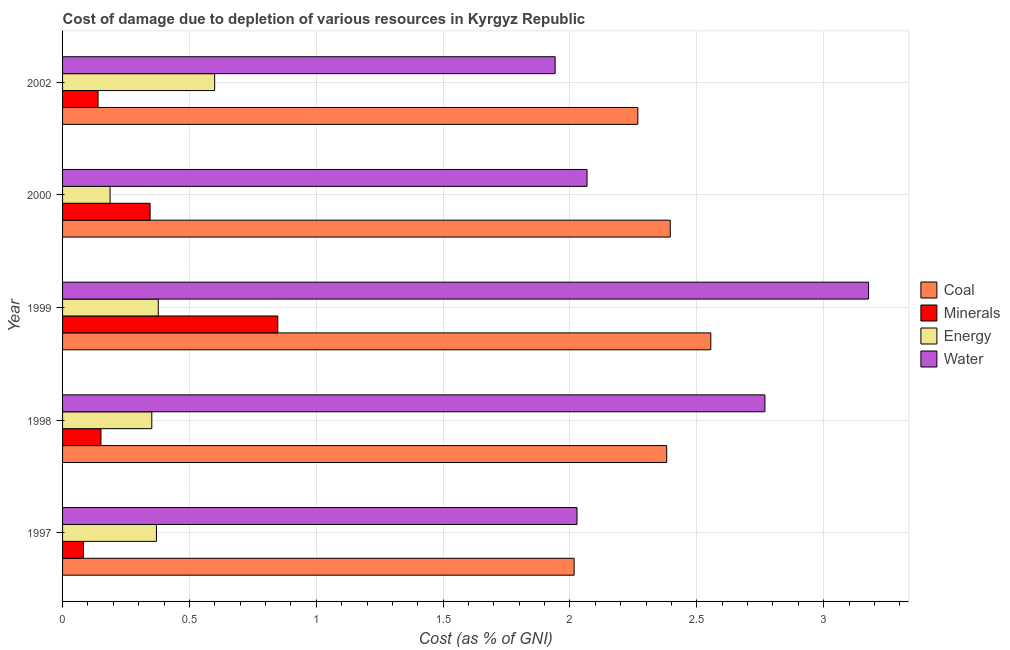How many different coloured bars are there?
Your response must be concise. 4. Are the number of bars per tick equal to the number of legend labels?
Give a very brief answer. Yes. Are the number of bars on each tick of the Y-axis equal?
Provide a succinct answer. Yes. How many bars are there on the 3rd tick from the top?
Give a very brief answer. 4. In how many cases, is the number of bars for a given year not equal to the number of legend labels?
Give a very brief answer. 0. What is the cost of damage due to depletion of minerals in 1997?
Make the answer very short. 0.08. Across all years, what is the maximum cost of damage due to depletion of minerals?
Offer a very short reply. 0.85. Across all years, what is the minimum cost of damage due to depletion of minerals?
Offer a very short reply. 0.08. In which year was the cost of damage due to depletion of energy minimum?
Keep it short and to the point. 2000. What is the total cost of damage due to depletion of coal in the graph?
Give a very brief answer. 11.62. What is the difference between the cost of damage due to depletion of minerals in 1997 and that in 1999?
Keep it short and to the point. -0.77. What is the difference between the cost of damage due to depletion of minerals in 2002 and the cost of damage due to depletion of water in 1998?
Your answer should be very brief. -2.63. What is the average cost of damage due to depletion of minerals per year?
Your answer should be very brief. 0.31. In the year 2000, what is the difference between the cost of damage due to depletion of energy and cost of damage due to depletion of minerals?
Your answer should be very brief. -0.16. In how many years, is the cost of damage due to depletion of energy greater than 1.7 %?
Offer a terse response. 0. What is the ratio of the cost of damage due to depletion of minerals in 2000 to that in 2002?
Provide a succinct answer. 2.47. Is the difference between the cost of damage due to depletion of water in 1997 and 1999 greater than the difference between the cost of damage due to depletion of minerals in 1997 and 1999?
Your response must be concise. No. What is the difference between the highest and the second highest cost of damage due to depletion of minerals?
Provide a short and direct response. 0.5. What is the difference between the highest and the lowest cost of damage due to depletion of energy?
Provide a short and direct response. 0.41. In how many years, is the cost of damage due to depletion of coal greater than the average cost of damage due to depletion of coal taken over all years?
Your answer should be very brief. 3. Is the sum of the cost of damage due to depletion of coal in 1998 and 1999 greater than the maximum cost of damage due to depletion of energy across all years?
Keep it short and to the point. Yes. What does the 3rd bar from the top in 1998 represents?
Provide a short and direct response. Minerals. What does the 2nd bar from the bottom in 2002 represents?
Give a very brief answer. Minerals. Is it the case that in every year, the sum of the cost of damage due to depletion of coal and cost of damage due to depletion of minerals is greater than the cost of damage due to depletion of energy?
Provide a succinct answer. Yes. How many bars are there?
Ensure brevity in your answer.  20. Does the graph contain grids?
Offer a terse response. Yes. How many legend labels are there?
Ensure brevity in your answer.  4. How are the legend labels stacked?
Provide a succinct answer. Vertical. What is the title of the graph?
Your answer should be compact. Cost of damage due to depletion of various resources in Kyrgyz Republic . What is the label or title of the X-axis?
Your response must be concise. Cost (as % of GNI). What is the Cost (as % of GNI) in Coal in 1997?
Your answer should be very brief. 2.02. What is the Cost (as % of GNI) in Minerals in 1997?
Offer a very short reply. 0.08. What is the Cost (as % of GNI) in Energy in 1997?
Keep it short and to the point. 0.37. What is the Cost (as % of GNI) of Water in 1997?
Your answer should be very brief. 2.03. What is the Cost (as % of GNI) of Coal in 1998?
Provide a succinct answer. 2.38. What is the Cost (as % of GNI) in Minerals in 1998?
Offer a very short reply. 0.15. What is the Cost (as % of GNI) in Energy in 1998?
Ensure brevity in your answer.  0.35. What is the Cost (as % of GNI) in Water in 1998?
Ensure brevity in your answer.  2.77. What is the Cost (as % of GNI) in Coal in 1999?
Your answer should be compact. 2.56. What is the Cost (as % of GNI) of Minerals in 1999?
Provide a succinct answer. 0.85. What is the Cost (as % of GNI) in Energy in 1999?
Give a very brief answer. 0.38. What is the Cost (as % of GNI) of Water in 1999?
Offer a very short reply. 3.18. What is the Cost (as % of GNI) in Coal in 2000?
Keep it short and to the point. 2.4. What is the Cost (as % of GNI) of Minerals in 2000?
Offer a very short reply. 0.35. What is the Cost (as % of GNI) of Energy in 2000?
Give a very brief answer. 0.19. What is the Cost (as % of GNI) of Water in 2000?
Offer a very short reply. 2.07. What is the Cost (as % of GNI) of Coal in 2002?
Keep it short and to the point. 2.27. What is the Cost (as % of GNI) of Minerals in 2002?
Your answer should be very brief. 0.14. What is the Cost (as % of GNI) in Energy in 2002?
Keep it short and to the point. 0.6. What is the Cost (as % of GNI) in Water in 2002?
Your response must be concise. 1.94. Across all years, what is the maximum Cost (as % of GNI) of Coal?
Your answer should be very brief. 2.56. Across all years, what is the maximum Cost (as % of GNI) in Minerals?
Keep it short and to the point. 0.85. Across all years, what is the maximum Cost (as % of GNI) in Energy?
Your response must be concise. 0.6. Across all years, what is the maximum Cost (as % of GNI) of Water?
Provide a succinct answer. 3.18. Across all years, what is the minimum Cost (as % of GNI) of Coal?
Provide a short and direct response. 2.02. Across all years, what is the minimum Cost (as % of GNI) in Minerals?
Provide a short and direct response. 0.08. Across all years, what is the minimum Cost (as % of GNI) in Energy?
Offer a very short reply. 0.19. Across all years, what is the minimum Cost (as % of GNI) in Water?
Make the answer very short. 1.94. What is the total Cost (as % of GNI) in Coal in the graph?
Offer a very short reply. 11.62. What is the total Cost (as % of GNI) in Minerals in the graph?
Make the answer very short. 1.57. What is the total Cost (as % of GNI) in Energy in the graph?
Make the answer very short. 1.89. What is the total Cost (as % of GNI) in Water in the graph?
Offer a terse response. 11.98. What is the difference between the Cost (as % of GNI) of Coal in 1997 and that in 1998?
Provide a short and direct response. -0.36. What is the difference between the Cost (as % of GNI) of Minerals in 1997 and that in 1998?
Ensure brevity in your answer.  -0.07. What is the difference between the Cost (as % of GNI) in Energy in 1997 and that in 1998?
Make the answer very short. 0.02. What is the difference between the Cost (as % of GNI) in Water in 1997 and that in 1998?
Ensure brevity in your answer.  -0.74. What is the difference between the Cost (as % of GNI) in Coal in 1997 and that in 1999?
Provide a succinct answer. -0.54. What is the difference between the Cost (as % of GNI) in Minerals in 1997 and that in 1999?
Offer a terse response. -0.77. What is the difference between the Cost (as % of GNI) of Energy in 1997 and that in 1999?
Ensure brevity in your answer.  -0.01. What is the difference between the Cost (as % of GNI) in Water in 1997 and that in 1999?
Keep it short and to the point. -1.15. What is the difference between the Cost (as % of GNI) in Coal in 1997 and that in 2000?
Your answer should be very brief. -0.38. What is the difference between the Cost (as % of GNI) of Minerals in 1997 and that in 2000?
Your answer should be compact. -0.26. What is the difference between the Cost (as % of GNI) of Energy in 1997 and that in 2000?
Offer a very short reply. 0.18. What is the difference between the Cost (as % of GNI) in Water in 1997 and that in 2000?
Your answer should be very brief. -0.04. What is the difference between the Cost (as % of GNI) in Coal in 1997 and that in 2002?
Provide a short and direct response. -0.25. What is the difference between the Cost (as % of GNI) in Minerals in 1997 and that in 2002?
Give a very brief answer. -0.06. What is the difference between the Cost (as % of GNI) of Energy in 1997 and that in 2002?
Your response must be concise. -0.23. What is the difference between the Cost (as % of GNI) in Water in 1997 and that in 2002?
Provide a succinct answer. 0.09. What is the difference between the Cost (as % of GNI) of Coal in 1998 and that in 1999?
Keep it short and to the point. -0.17. What is the difference between the Cost (as % of GNI) in Minerals in 1998 and that in 1999?
Your response must be concise. -0.7. What is the difference between the Cost (as % of GNI) of Energy in 1998 and that in 1999?
Keep it short and to the point. -0.03. What is the difference between the Cost (as % of GNI) in Water in 1998 and that in 1999?
Make the answer very short. -0.41. What is the difference between the Cost (as % of GNI) of Coal in 1998 and that in 2000?
Ensure brevity in your answer.  -0.01. What is the difference between the Cost (as % of GNI) in Minerals in 1998 and that in 2000?
Make the answer very short. -0.19. What is the difference between the Cost (as % of GNI) of Energy in 1998 and that in 2000?
Offer a terse response. 0.16. What is the difference between the Cost (as % of GNI) in Water in 1998 and that in 2000?
Your response must be concise. 0.7. What is the difference between the Cost (as % of GNI) of Coal in 1998 and that in 2002?
Give a very brief answer. 0.11. What is the difference between the Cost (as % of GNI) in Minerals in 1998 and that in 2002?
Keep it short and to the point. 0.01. What is the difference between the Cost (as % of GNI) in Energy in 1998 and that in 2002?
Offer a terse response. -0.25. What is the difference between the Cost (as % of GNI) in Water in 1998 and that in 2002?
Provide a succinct answer. 0.83. What is the difference between the Cost (as % of GNI) in Coal in 1999 and that in 2000?
Your response must be concise. 0.16. What is the difference between the Cost (as % of GNI) of Minerals in 1999 and that in 2000?
Provide a short and direct response. 0.5. What is the difference between the Cost (as % of GNI) in Energy in 1999 and that in 2000?
Keep it short and to the point. 0.19. What is the difference between the Cost (as % of GNI) of Water in 1999 and that in 2000?
Keep it short and to the point. 1.11. What is the difference between the Cost (as % of GNI) of Coal in 1999 and that in 2002?
Provide a short and direct response. 0.29. What is the difference between the Cost (as % of GNI) of Minerals in 1999 and that in 2002?
Your answer should be compact. 0.71. What is the difference between the Cost (as % of GNI) of Energy in 1999 and that in 2002?
Give a very brief answer. -0.22. What is the difference between the Cost (as % of GNI) in Water in 1999 and that in 2002?
Provide a succinct answer. 1.24. What is the difference between the Cost (as % of GNI) of Coal in 2000 and that in 2002?
Provide a succinct answer. 0.13. What is the difference between the Cost (as % of GNI) in Minerals in 2000 and that in 2002?
Provide a short and direct response. 0.21. What is the difference between the Cost (as % of GNI) in Energy in 2000 and that in 2002?
Provide a short and direct response. -0.41. What is the difference between the Cost (as % of GNI) in Water in 2000 and that in 2002?
Ensure brevity in your answer.  0.13. What is the difference between the Cost (as % of GNI) in Coal in 1997 and the Cost (as % of GNI) in Minerals in 1998?
Your response must be concise. 1.87. What is the difference between the Cost (as % of GNI) in Coal in 1997 and the Cost (as % of GNI) in Energy in 1998?
Provide a succinct answer. 1.66. What is the difference between the Cost (as % of GNI) of Coal in 1997 and the Cost (as % of GNI) of Water in 1998?
Make the answer very short. -0.75. What is the difference between the Cost (as % of GNI) of Minerals in 1997 and the Cost (as % of GNI) of Energy in 1998?
Offer a terse response. -0.27. What is the difference between the Cost (as % of GNI) in Minerals in 1997 and the Cost (as % of GNI) in Water in 1998?
Provide a succinct answer. -2.69. What is the difference between the Cost (as % of GNI) in Energy in 1997 and the Cost (as % of GNI) in Water in 1998?
Offer a terse response. -2.4. What is the difference between the Cost (as % of GNI) in Coal in 1997 and the Cost (as % of GNI) in Minerals in 1999?
Make the answer very short. 1.17. What is the difference between the Cost (as % of GNI) in Coal in 1997 and the Cost (as % of GNI) in Energy in 1999?
Keep it short and to the point. 1.64. What is the difference between the Cost (as % of GNI) in Coal in 1997 and the Cost (as % of GNI) in Water in 1999?
Your answer should be compact. -1.16. What is the difference between the Cost (as % of GNI) of Minerals in 1997 and the Cost (as % of GNI) of Energy in 1999?
Your answer should be very brief. -0.29. What is the difference between the Cost (as % of GNI) of Minerals in 1997 and the Cost (as % of GNI) of Water in 1999?
Offer a very short reply. -3.09. What is the difference between the Cost (as % of GNI) of Energy in 1997 and the Cost (as % of GNI) of Water in 1999?
Your answer should be very brief. -2.81. What is the difference between the Cost (as % of GNI) in Coal in 1997 and the Cost (as % of GNI) in Minerals in 2000?
Your answer should be compact. 1.67. What is the difference between the Cost (as % of GNI) of Coal in 1997 and the Cost (as % of GNI) of Energy in 2000?
Offer a terse response. 1.83. What is the difference between the Cost (as % of GNI) of Coal in 1997 and the Cost (as % of GNI) of Water in 2000?
Offer a terse response. -0.05. What is the difference between the Cost (as % of GNI) of Minerals in 1997 and the Cost (as % of GNI) of Energy in 2000?
Keep it short and to the point. -0.1. What is the difference between the Cost (as % of GNI) of Minerals in 1997 and the Cost (as % of GNI) of Water in 2000?
Offer a terse response. -1.98. What is the difference between the Cost (as % of GNI) in Energy in 1997 and the Cost (as % of GNI) in Water in 2000?
Offer a terse response. -1.7. What is the difference between the Cost (as % of GNI) in Coal in 1997 and the Cost (as % of GNI) in Minerals in 2002?
Make the answer very short. 1.88. What is the difference between the Cost (as % of GNI) in Coal in 1997 and the Cost (as % of GNI) in Energy in 2002?
Your answer should be compact. 1.42. What is the difference between the Cost (as % of GNI) of Coal in 1997 and the Cost (as % of GNI) of Water in 2002?
Give a very brief answer. 0.07. What is the difference between the Cost (as % of GNI) of Minerals in 1997 and the Cost (as % of GNI) of Energy in 2002?
Make the answer very short. -0.52. What is the difference between the Cost (as % of GNI) of Minerals in 1997 and the Cost (as % of GNI) of Water in 2002?
Keep it short and to the point. -1.86. What is the difference between the Cost (as % of GNI) in Energy in 1997 and the Cost (as % of GNI) in Water in 2002?
Provide a succinct answer. -1.57. What is the difference between the Cost (as % of GNI) of Coal in 1998 and the Cost (as % of GNI) of Minerals in 1999?
Your response must be concise. 1.53. What is the difference between the Cost (as % of GNI) of Coal in 1998 and the Cost (as % of GNI) of Energy in 1999?
Keep it short and to the point. 2. What is the difference between the Cost (as % of GNI) of Coal in 1998 and the Cost (as % of GNI) of Water in 1999?
Ensure brevity in your answer.  -0.8. What is the difference between the Cost (as % of GNI) in Minerals in 1998 and the Cost (as % of GNI) in Energy in 1999?
Provide a short and direct response. -0.23. What is the difference between the Cost (as % of GNI) of Minerals in 1998 and the Cost (as % of GNI) of Water in 1999?
Provide a short and direct response. -3.03. What is the difference between the Cost (as % of GNI) in Energy in 1998 and the Cost (as % of GNI) in Water in 1999?
Offer a very short reply. -2.83. What is the difference between the Cost (as % of GNI) of Coal in 1998 and the Cost (as % of GNI) of Minerals in 2000?
Your answer should be compact. 2.04. What is the difference between the Cost (as % of GNI) in Coal in 1998 and the Cost (as % of GNI) in Energy in 2000?
Ensure brevity in your answer.  2.19. What is the difference between the Cost (as % of GNI) of Coal in 1998 and the Cost (as % of GNI) of Water in 2000?
Give a very brief answer. 0.31. What is the difference between the Cost (as % of GNI) of Minerals in 1998 and the Cost (as % of GNI) of Energy in 2000?
Make the answer very short. -0.04. What is the difference between the Cost (as % of GNI) in Minerals in 1998 and the Cost (as % of GNI) in Water in 2000?
Provide a short and direct response. -1.92. What is the difference between the Cost (as % of GNI) of Energy in 1998 and the Cost (as % of GNI) of Water in 2000?
Provide a succinct answer. -1.72. What is the difference between the Cost (as % of GNI) in Coal in 1998 and the Cost (as % of GNI) in Minerals in 2002?
Your answer should be very brief. 2.24. What is the difference between the Cost (as % of GNI) of Coal in 1998 and the Cost (as % of GNI) of Energy in 2002?
Make the answer very short. 1.78. What is the difference between the Cost (as % of GNI) of Coal in 1998 and the Cost (as % of GNI) of Water in 2002?
Give a very brief answer. 0.44. What is the difference between the Cost (as % of GNI) of Minerals in 1998 and the Cost (as % of GNI) of Energy in 2002?
Your answer should be compact. -0.45. What is the difference between the Cost (as % of GNI) in Minerals in 1998 and the Cost (as % of GNI) in Water in 2002?
Give a very brief answer. -1.79. What is the difference between the Cost (as % of GNI) in Energy in 1998 and the Cost (as % of GNI) in Water in 2002?
Your answer should be very brief. -1.59. What is the difference between the Cost (as % of GNI) in Coal in 1999 and the Cost (as % of GNI) in Minerals in 2000?
Provide a short and direct response. 2.21. What is the difference between the Cost (as % of GNI) of Coal in 1999 and the Cost (as % of GNI) of Energy in 2000?
Ensure brevity in your answer.  2.37. What is the difference between the Cost (as % of GNI) of Coal in 1999 and the Cost (as % of GNI) of Water in 2000?
Provide a succinct answer. 0.49. What is the difference between the Cost (as % of GNI) of Minerals in 1999 and the Cost (as % of GNI) of Energy in 2000?
Provide a succinct answer. 0.66. What is the difference between the Cost (as % of GNI) in Minerals in 1999 and the Cost (as % of GNI) in Water in 2000?
Provide a short and direct response. -1.22. What is the difference between the Cost (as % of GNI) of Energy in 1999 and the Cost (as % of GNI) of Water in 2000?
Your answer should be compact. -1.69. What is the difference between the Cost (as % of GNI) of Coal in 1999 and the Cost (as % of GNI) of Minerals in 2002?
Give a very brief answer. 2.42. What is the difference between the Cost (as % of GNI) in Coal in 1999 and the Cost (as % of GNI) in Energy in 2002?
Provide a short and direct response. 1.96. What is the difference between the Cost (as % of GNI) in Coal in 1999 and the Cost (as % of GNI) in Water in 2002?
Your answer should be very brief. 0.61. What is the difference between the Cost (as % of GNI) of Minerals in 1999 and the Cost (as % of GNI) of Energy in 2002?
Your answer should be very brief. 0.25. What is the difference between the Cost (as % of GNI) in Minerals in 1999 and the Cost (as % of GNI) in Water in 2002?
Offer a very short reply. -1.09. What is the difference between the Cost (as % of GNI) in Energy in 1999 and the Cost (as % of GNI) in Water in 2002?
Your answer should be very brief. -1.56. What is the difference between the Cost (as % of GNI) of Coal in 2000 and the Cost (as % of GNI) of Minerals in 2002?
Give a very brief answer. 2.26. What is the difference between the Cost (as % of GNI) of Coal in 2000 and the Cost (as % of GNI) of Energy in 2002?
Offer a terse response. 1.8. What is the difference between the Cost (as % of GNI) in Coal in 2000 and the Cost (as % of GNI) in Water in 2002?
Provide a short and direct response. 0.45. What is the difference between the Cost (as % of GNI) in Minerals in 2000 and the Cost (as % of GNI) in Energy in 2002?
Provide a short and direct response. -0.25. What is the difference between the Cost (as % of GNI) in Minerals in 2000 and the Cost (as % of GNI) in Water in 2002?
Your response must be concise. -1.6. What is the difference between the Cost (as % of GNI) in Energy in 2000 and the Cost (as % of GNI) in Water in 2002?
Provide a succinct answer. -1.75. What is the average Cost (as % of GNI) of Coal per year?
Your response must be concise. 2.32. What is the average Cost (as % of GNI) in Minerals per year?
Your response must be concise. 0.31. What is the average Cost (as % of GNI) in Energy per year?
Offer a terse response. 0.38. What is the average Cost (as % of GNI) of Water per year?
Give a very brief answer. 2.4. In the year 1997, what is the difference between the Cost (as % of GNI) in Coal and Cost (as % of GNI) in Minerals?
Provide a short and direct response. 1.93. In the year 1997, what is the difference between the Cost (as % of GNI) of Coal and Cost (as % of GNI) of Energy?
Your answer should be compact. 1.65. In the year 1997, what is the difference between the Cost (as % of GNI) of Coal and Cost (as % of GNI) of Water?
Keep it short and to the point. -0.01. In the year 1997, what is the difference between the Cost (as % of GNI) in Minerals and Cost (as % of GNI) in Energy?
Offer a very short reply. -0.29. In the year 1997, what is the difference between the Cost (as % of GNI) in Minerals and Cost (as % of GNI) in Water?
Provide a succinct answer. -1.95. In the year 1997, what is the difference between the Cost (as % of GNI) in Energy and Cost (as % of GNI) in Water?
Offer a terse response. -1.66. In the year 1998, what is the difference between the Cost (as % of GNI) in Coal and Cost (as % of GNI) in Minerals?
Your answer should be very brief. 2.23. In the year 1998, what is the difference between the Cost (as % of GNI) of Coal and Cost (as % of GNI) of Energy?
Your answer should be compact. 2.03. In the year 1998, what is the difference between the Cost (as % of GNI) of Coal and Cost (as % of GNI) of Water?
Offer a terse response. -0.39. In the year 1998, what is the difference between the Cost (as % of GNI) in Minerals and Cost (as % of GNI) in Energy?
Offer a terse response. -0.2. In the year 1998, what is the difference between the Cost (as % of GNI) of Minerals and Cost (as % of GNI) of Water?
Your response must be concise. -2.62. In the year 1998, what is the difference between the Cost (as % of GNI) in Energy and Cost (as % of GNI) in Water?
Offer a terse response. -2.42. In the year 1999, what is the difference between the Cost (as % of GNI) in Coal and Cost (as % of GNI) in Minerals?
Offer a very short reply. 1.71. In the year 1999, what is the difference between the Cost (as % of GNI) of Coal and Cost (as % of GNI) of Energy?
Your answer should be very brief. 2.18. In the year 1999, what is the difference between the Cost (as % of GNI) in Coal and Cost (as % of GNI) in Water?
Offer a very short reply. -0.62. In the year 1999, what is the difference between the Cost (as % of GNI) in Minerals and Cost (as % of GNI) in Energy?
Offer a terse response. 0.47. In the year 1999, what is the difference between the Cost (as % of GNI) in Minerals and Cost (as % of GNI) in Water?
Offer a terse response. -2.33. In the year 1999, what is the difference between the Cost (as % of GNI) of Energy and Cost (as % of GNI) of Water?
Provide a succinct answer. -2.8. In the year 2000, what is the difference between the Cost (as % of GNI) of Coal and Cost (as % of GNI) of Minerals?
Ensure brevity in your answer.  2.05. In the year 2000, what is the difference between the Cost (as % of GNI) in Coal and Cost (as % of GNI) in Energy?
Give a very brief answer. 2.21. In the year 2000, what is the difference between the Cost (as % of GNI) in Coal and Cost (as % of GNI) in Water?
Provide a short and direct response. 0.33. In the year 2000, what is the difference between the Cost (as % of GNI) of Minerals and Cost (as % of GNI) of Energy?
Ensure brevity in your answer.  0.16. In the year 2000, what is the difference between the Cost (as % of GNI) in Minerals and Cost (as % of GNI) in Water?
Your response must be concise. -1.72. In the year 2000, what is the difference between the Cost (as % of GNI) in Energy and Cost (as % of GNI) in Water?
Your answer should be very brief. -1.88. In the year 2002, what is the difference between the Cost (as % of GNI) in Coal and Cost (as % of GNI) in Minerals?
Give a very brief answer. 2.13. In the year 2002, what is the difference between the Cost (as % of GNI) of Coal and Cost (as % of GNI) of Energy?
Provide a succinct answer. 1.67. In the year 2002, what is the difference between the Cost (as % of GNI) of Coal and Cost (as % of GNI) of Water?
Your response must be concise. 0.33. In the year 2002, what is the difference between the Cost (as % of GNI) of Minerals and Cost (as % of GNI) of Energy?
Offer a terse response. -0.46. In the year 2002, what is the difference between the Cost (as % of GNI) in Minerals and Cost (as % of GNI) in Water?
Provide a succinct answer. -1.8. In the year 2002, what is the difference between the Cost (as % of GNI) in Energy and Cost (as % of GNI) in Water?
Offer a very short reply. -1.34. What is the ratio of the Cost (as % of GNI) of Coal in 1997 to that in 1998?
Provide a succinct answer. 0.85. What is the ratio of the Cost (as % of GNI) in Minerals in 1997 to that in 1998?
Your answer should be very brief. 0.54. What is the ratio of the Cost (as % of GNI) in Energy in 1997 to that in 1998?
Offer a very short reply. 1.05. What is the ratio of the Cost (as % of GNI) of Water in 1997 to that in 1998?
Make the answer very short. 0.73. What is the ratio of the Cost (as % of GNI) of Coal in 1997 to that in 1999?
Provide a succinct answer. 0.79. What is the ratio of the Cost (as % of GNI) of Minerals in 1997 to that in 1999?
Give a very brief answer. 0.1. What is the ratio of the Cost (as % of GNI) of Energy in 1997 to that in 1999?
Ensure brevity in your answer.  0.98. What is the ratio of the Cost (as % of GNI) of Water in 1997 to that in 1999?
Offer a terse response. 0.64. What is the ratio of the Cost (as % of GNI) of Coal in 1997 to that in 2000?
Make the answer very short. 0.84. What is the ratio of the Cost (as % of GNI) of Minerals in 1997 to that in 2000?
Provide a succinct answer. 0.24. What is the ratio of the Cost (as % of GNI) in Energy in 1997 to that in 2000?
Keep it short and to the point. 1.98. What is the ratio of the Cost (as % of GNI) in Water in 1997 to that in 2000?
Give a very brief answer. 0.98. What is the ratio of the Cost (as % of GNI) in Coal in 1997 to that in 2002?
Offer a terse response. 0.89. What is the ratio of the Cost (as % of GNI) in Minerals in 1997 to that in 2002?
Give a very brief answer. 0.59. What is the ratio of the Cost (as % of GNI) in Energy in 1997 to that in 2002?
Provide a short and direct response. 0.62. What is the ratio of the Cost (as % of GNI) of Water in 1997 to that in 2002?
Give a very brief answer. 1.04. What is the ratio of the Cost (as % of GNI) in Coal in 1998 to that in 1999?
Keep it short and to the point. 0.93. What is the ratio of the Cost (as % of GNI) in Minerals in 1998 to that in 1999?
Provide a short and direct response. 0.18. What is the ratio of the Cost (as % of GNI) in Energy in 1998 to that in 1999?
Ensure brevity in your answer.  0.93. What is the ratio of the Cost (as % of GNI) in Water in 1998 to that in 1999?
Provide a succinct answer. 0.87. What is the ratio of the Cost (as % of GNI) in Coal in 1998 to that in 2000?
Keep it short and to the point. 0.99. What is the ratio of the Cost (as % of GNI) in Minerals in 1998 to that in 2000?
Make the answer very short. 0.44. What is the ratio of the Cost (as % of GNI) in Energy in 1998 to that in 2000?
Your response must be concise. 1.88. What is the ratio of the Cost (as % of GNI) in Water in 1998 to that in 2000?
Keep it short and to the point. 1.34. What is the ratio of the Cost (as % of GNI) in Coal in 1998 to that in 2002?
Provide a succinct answer. 1.05. What is the ratio of the Cost (as % of GNI) in Minerals in 1998 to that in 2002?
Your response must be concise. 1.08. What is the ratio of the Cost (as % of GNI) in Energy in 1998 to that in 2002?
Keep it short and to the point. 0.59. What is the ratio of the Cost (as % of GNI) of Water in 1998 to that in 2002?
Provide a short and direct response. 1.43. What is the ratio of the Cost (as % of GNI) of Coal in 1999 to that in 2000?
Offer a very short reply. 1.07. What is the ratio of the Cost (as % of GNI) in Minerals in 1999 to that in 2000?
Give a very brief answer. 2.46. What is the ratio of the Cost (as % of GNI) of Energy in 1999 to that in 2000?
Make the answer very short. 2.01. What is the ratio of the Cost (as % of GNI) of Water in 1999 to that in 2000?
Give a very brief answer. 1.54. What is the ratio of the Cost (as % of GNI) of Coal in 1999 to that in 2002?
Provide a short and direct response. 1.13. What is the ratio of the Cost (as % of GNI) of Minerals in 1999 to that in 2002?
Ensure brevity in your answer.  6.07. What is the ratio of the Cost (as % of GNI) of Energy in 1999 to that in 2002?
Provide a succinct answer. 0.63. What is the ratio of the Cost (as % of GNI) of Water in 1999 to that in 2002?
Your answer should be compact. 1.64. What is the ratio of the Cost (as % of GNI) in Coal in 2000 to that in 2002?
Provide a short and direct response. 1.06. What is the ratio of the Cost (as % of GNI) of Minerals in 2000 to that in 2002?
Your response must be concise. 2.47. What is the ratio of the Cost (as % of GNI) in Energy in 2000 to that in 2002?
Your answer should be very brief. 0.31. What is the ratio of the Cost (as % of GNI) of Water in 2000 to that in 2002?
Provide a succinct answer. 1.06. What is the difference between the highest and the second highest Cost (as % of GNI) in Coal?
Provide a short and direct response. 0.16. What is the difference between the highest and the second highest Cost (as % of GNI) in Minerals?
Make the answer very short. 0.5. What is the difference between the highest and the second highest Cost (as % of GNI) in Energy?
Provide a succinct answer. 0.22. What is the difference between the highest and the second highest Cost (as % of GNI) of Water?
Provide a succinct answer. 0.41. What is the difference between the highest and the lowest Cost (as % of GNI) in Coal?
Make the answer very short. 0.54. What is the difference between the highest and the lowest Cost (as % of GNI) of Minerals?
Provide a succinct answer. 0.77. What is the difference between the highest and the lowest Cost (as % of GNI) in Energy?
Offer a terse response. 0.41. What is the difference between the highest and the lowest Cost (as % of GNI) in Water?
Your response must be concise. 1.24. 